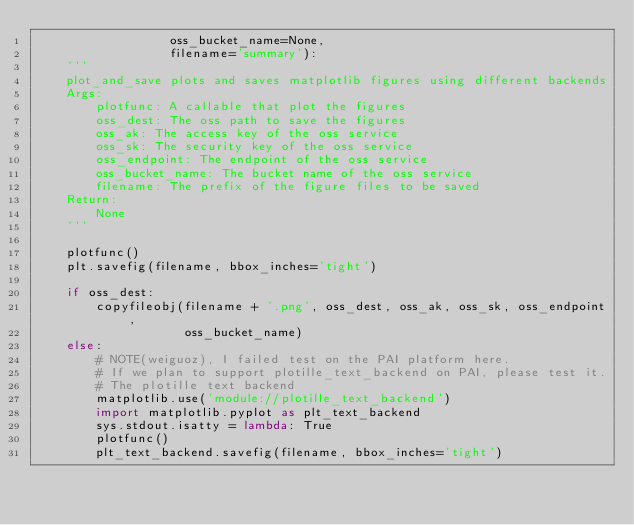<code> <loc_0><loc_0><loc_500><loc_500><_Python_>                  oss_bucket_name=None,
                  filename='summary'):
    '''
    plot_and_save plots and saves matplotlib figures using different backends
    Args:
        plotfunc: A callable that plot the figures
        oss_dest: The oss path to save the figures
        oss_ak: The access key of the oss service
        oss_sk: The security key of the oss service
        oss_endpoint: The endpoint of the oss service
        oss_bucket_name: The bucket name of the oss service
        filename: The prefix of the figure files to be saved
    Return:
        None
    '''

    plotfunc()
    plt.savefig(filename, bbox_inches='tight')

    if oss_dest:
        copyfileobj(filename + '.png', oss_dest, oss_ak, oss_sk, oss_endpoint,
                    oss_bucket_name)
    else:
        # NOTE(weiguoz), I failed test on the PAI platform here.
        # If we plan to support plotille_text_backend on PAI, please test it.
        # The plotille text backend
        matplotlib.use('module://plotille_text_backend')
        import matplotlib.pyplot as plt_text_backend
        sys.stdout.isatty = lambda: True
        plotfunc()
        plt_text_backend.savefig(filename, bbox_inches='tight')
</code> 